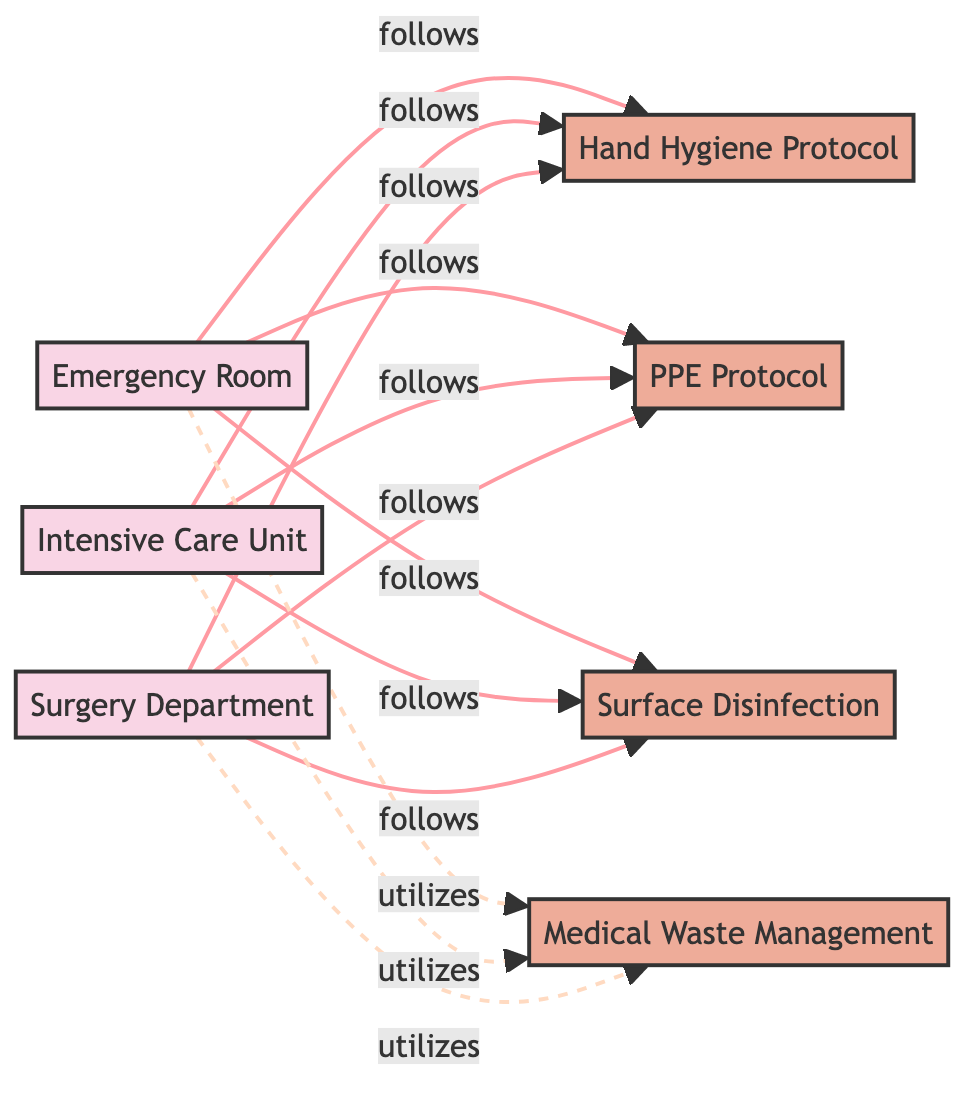What are the high-risk areas in the diagram? The diagram lists three high-risk areas: Emergency Room, Intensive Care Unit, and Surgery Department. These are clearly labeled as 'area' nodes.
Answer: Emergency Room, Intensive Care Unit, Surgery Department How many sanitation protocols are displayed? The diagram includes four specific sanitation protocols: Hand Hygiene Protocol, PPE Protocol, Surface Disinfection Protocol, and Waste Management. By counting the 'protocol' nodes, we find four.
Answer: Four Which area follows the Surface Disinfection Protocol? The diagram shows that the Emergency Room, Intensive Care Unit, and Surgery Department all follow the Surface Disinfection Protocol, indicated by the connections labeled "follows."
Answer: Emergency Room, Intensive Care Unit, Surgery Department What relationship do the high-risk areas have with Waste Management? The high-risk areas (Emergency Room, Intensive Care Unit, Surgery Department) utilize the Waste Management protocol, represented by the dashed lines labeled "utilizes."
Answer: Utilizes Which protocol is not followed by the Surgery Department? The diagram indicates that the Surgery Department follows all specified protocols: Hand Hygiene, PPE, and Surface Disinfection; thus, it follows none of them. However, all protocols are followed.
Answer: None How many connections does the Intensive Care Unit have in the diagram? The Intensive Care Unit has three connections to sanitation protocols (Hand Hygiene, PPE, and Surface Disinfection) and one connection to Waste Management, totaling four connections.
Answer: Four Which sanitation protocol is common among all high-risk areas? The Hand Hygiene Protocol is followed by all three high-risk areas, indicating its importance in infection control across these settings.
Answer: Hand Hygiene Protocol What type of relationships are shown between the areas and protocols in the diagram? The relationships between the areas and protocols are directional and labeled; the areas "follow" the protocols and "utilize" Waste Management, reflecting an action taken.
Answer: Follows and utilizes Which area utilizes Waste Management? All three high-risk areas—Emergency Room, Intensive Care Unit, and Surgery Department—utilize the Waste Management protocol, as indicated by the "utilizes" relationships in the diagram.
Answer: Emergency Room, Intensive Care Unit, Surgery Department 